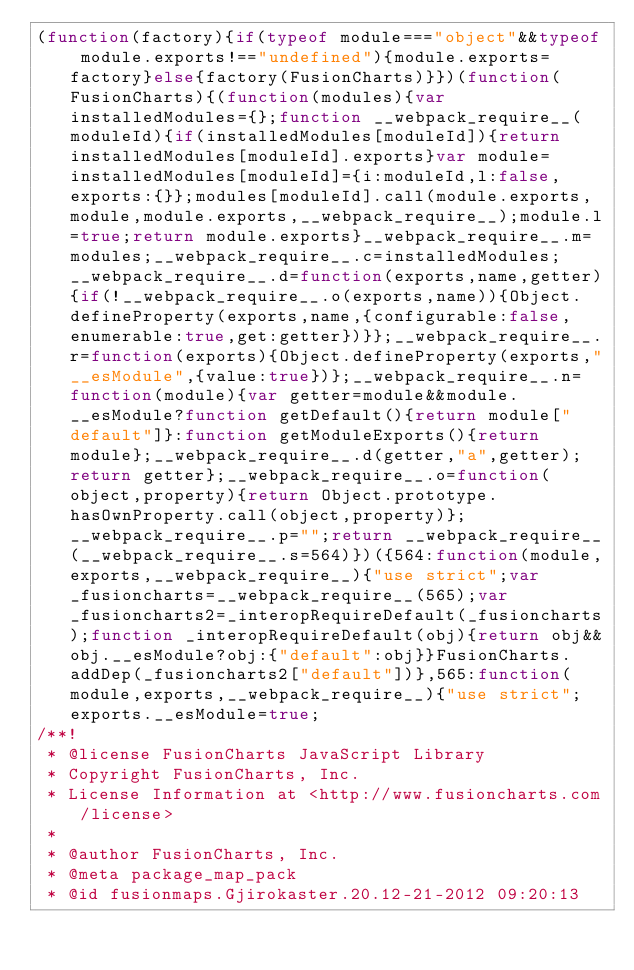<code> <loc_0><loc_0><loc_500><loc_500><_JavaScript_>(function(factory){if(typeof module==="object"&&typeof module.exports!=="undefined"){module.exports=factory}else{factory(FusionCharts)}})(function(FusionCharts){(function(modules){var installedModules={};function __webpack_require__(moduleId){if(installedModules[moduleId]){return installedModules[moduleId].exports}var module=installedModules[moduleId]={i:moduleId,l:false,exports:{}};modules[moduleId].call(module.exports,module,module.exports,__webpack_require__);module.l=true;return module.exports}__webpack_require__.m=modules;__webpack_require__.c=installedModules;__webpack_require__.d=function(exports,name,getter){if(!__webpack_require__.o(exports,name)){Object.defineProperty(exports,name,{configurable:false,enumerable:true,get:getter})}};__webpack_require__.r=function(exports){Object.defineProperty(exports,"__esModule",{value:true})};__webpack_require__.n=function(module){var getter=module&&module.__esModule?function getDefault(){return module["default"]}:function getModuleExports(){return module};__webpack_require__.d(getter,"a",getter);return getter};__webpack_require__.o=function(object,property){return Object.prototype.hasOwnProperty.call(object,property)};__webpack_require__.p="";return __webpack_require__(__webpack_require__.s=564)})({564:function(module,exports,__webpack_require__){"use strict";var _fusioncharts=__webpack_require__(565);var _fusioncharts2=_interopRequireDefault(_fusioncharts);function _interopRequireDefault(obj){return obj&&obj.__esModule?obj:{"default":obj}}FusionCharts.addDep(_fusioncharts2["default"])},565:function(module,exports,__webpack_require__){"use strict";exports.__esModule=true;
/**!
 * @license FusionCharts JavaScript Library
 * Copyright FusionCharts, Inc.
 * License Information at <http://www.fusioncharts.com/license>
 *
 * @author FusionCharts, Inc.
 * @meta package_map_pack
 * @id fusionmaps.Gjirokaster.20.12-21-2012 09:20:13</code> 